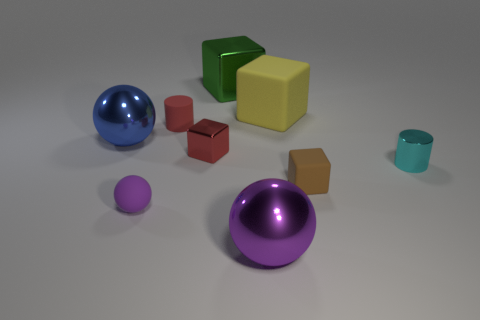How many other things are the same color as the rubber ball?
Your answer should be compact. 1. There is a red matte thing; is its size the same as the purple thing that is behind the big purple metallic ball?
Your answer should be very brief. Yes. What is the size of the purple object that is to the right of the tiny cylinder that is on the left side of the big purple ball?
Your answer should be compact. Large. What is the color of the tiny matte object that is the same shape as the big purple thing?
Provide a short and direct response. Purple. Does the brown thing have the same size as the rubber ball?
Offer a terse response. Yes. Is the number of yellow blocks to the left of the tiny purple thing the same as the number of small green metal cubes?
Your answer should be compact. Yes. Is there a tiny red metal thing that is right of the tiny rubber thing behind the tiny rubber cube?
Provide a succinct answer. Yes. What is the size of the shiny object that is behind the tiny cylinder behind the tiny metal object on the left side of the large yellow matte object?
Your answer should be compact. Large. There is a red block that is behind the matte block in front of the cyan thing; what is its material?
Keep it short and to the point. Metal. Is there a small red matte object that has the same shape as the yellow rubber object?
Your answer should be compact. No. 